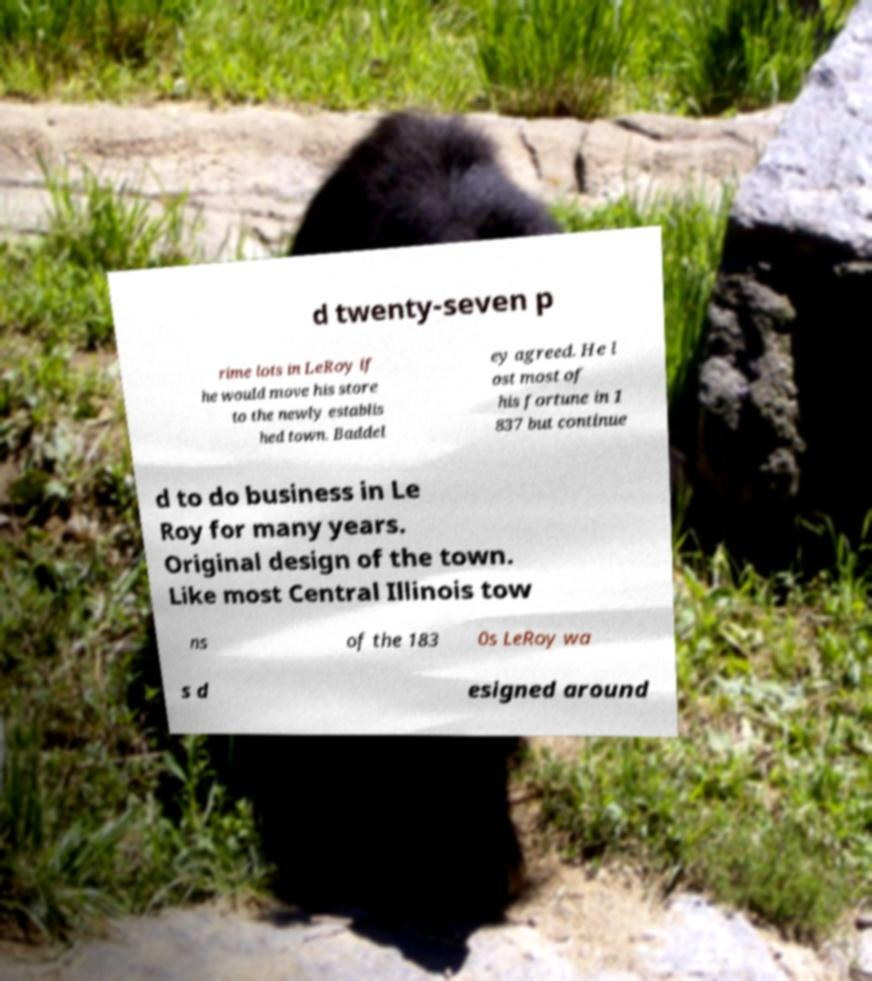Could you extract and type out the text from this image? d twenty-seven p rime lots in LeRoy if he would move his store to the newly establis hed town. Baddel ey agreed. He l ost most of his fortune in 1 837 but continue d to do business in Le Roy for many years. Original design of the town. Like most Central Illinois tow ns of the 183 0s LeRoy wa s d esigned around 